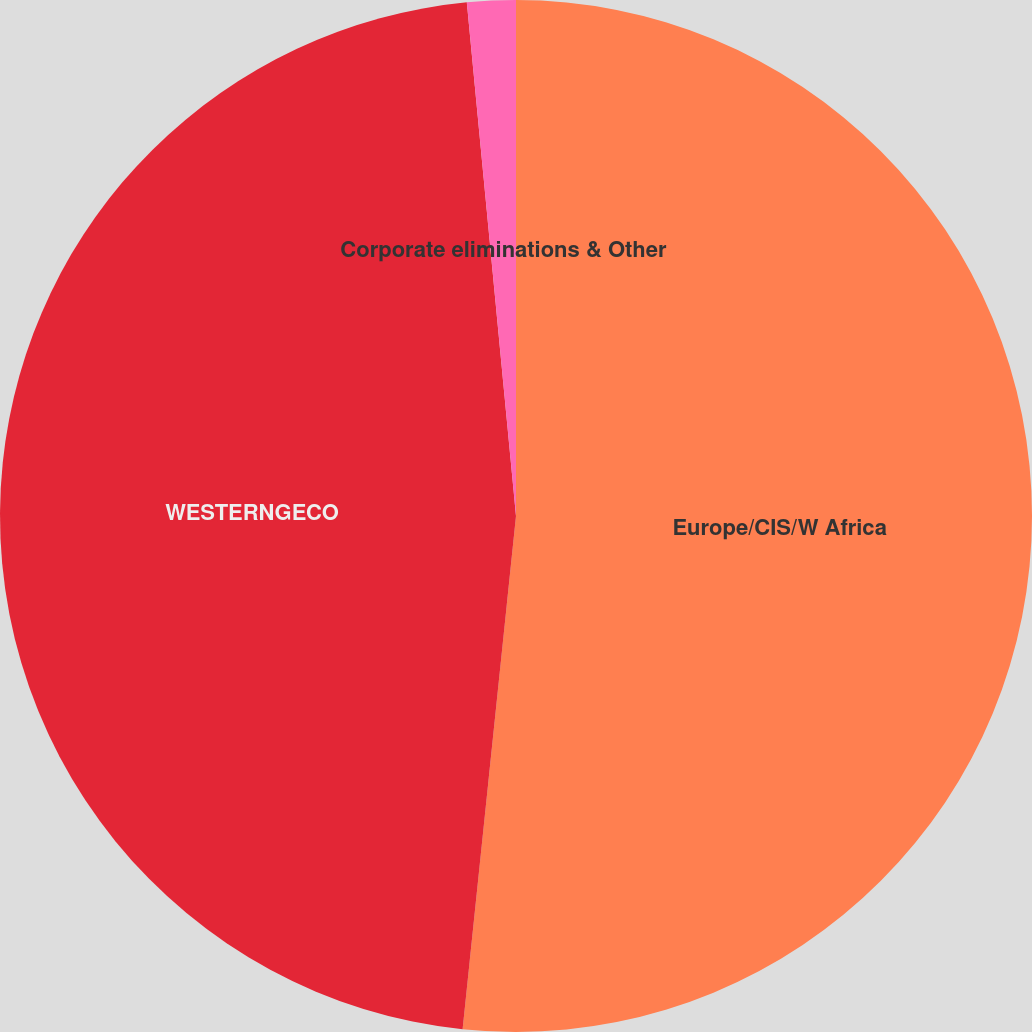Convert chart to OTSL. <chart><loc_0><loc_0><loc_500><loc_500><pie_chart><fcel>Europe/CIS/W Africa<fcel>WESTERNGECO<fcel>Corporate eliminations & Other<nl><fcel>51.65%<fcel>46.83%<fcel>1.52%<nl></chart> 